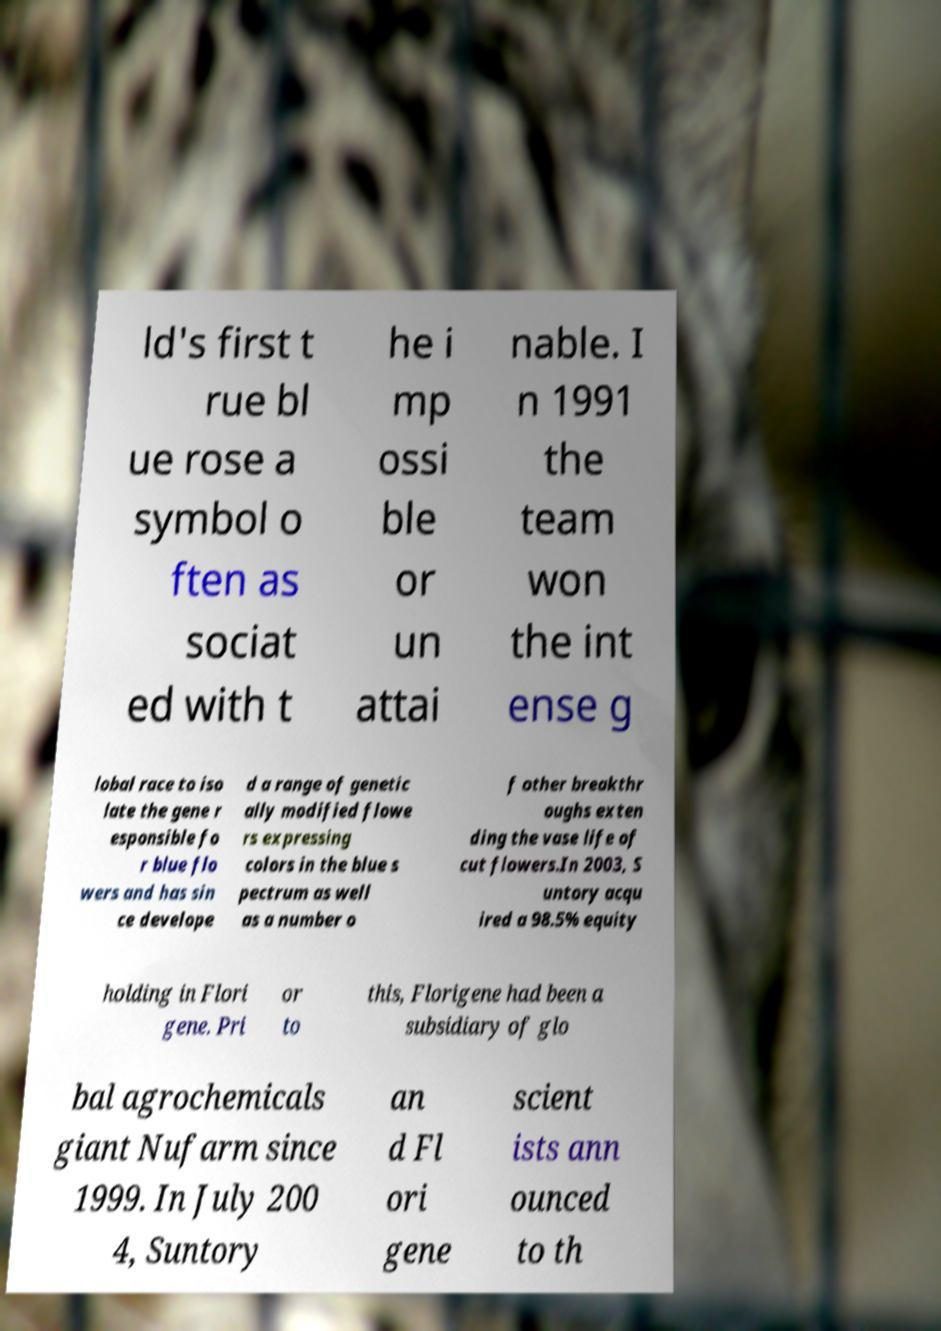Could you extract and type out the text from this image? ld's first t rue bl ue rose a symbol o ften as sociat ed with t he i mp ossi ble or un attai nable. I n 1991 the team won the int ense g lobal race to iso late the gene r esponsible fo r blue flo wers and has sin ce develope d a range of genetic ally modified flowe rs expressing colors in the blue s pectrum as well as a number o f other breakthr oughs exten ding the vase life of cut flowers.In 2003, S untory acqu ired a 98.5% equity holding in Flori gene. Pri or to this, Florigene had been a subsidiary of glo bal agrochemicals giant Nufarm since 1999. In July 200 4, Suntory an d Fl ori gene scient ists ann ounced to th 